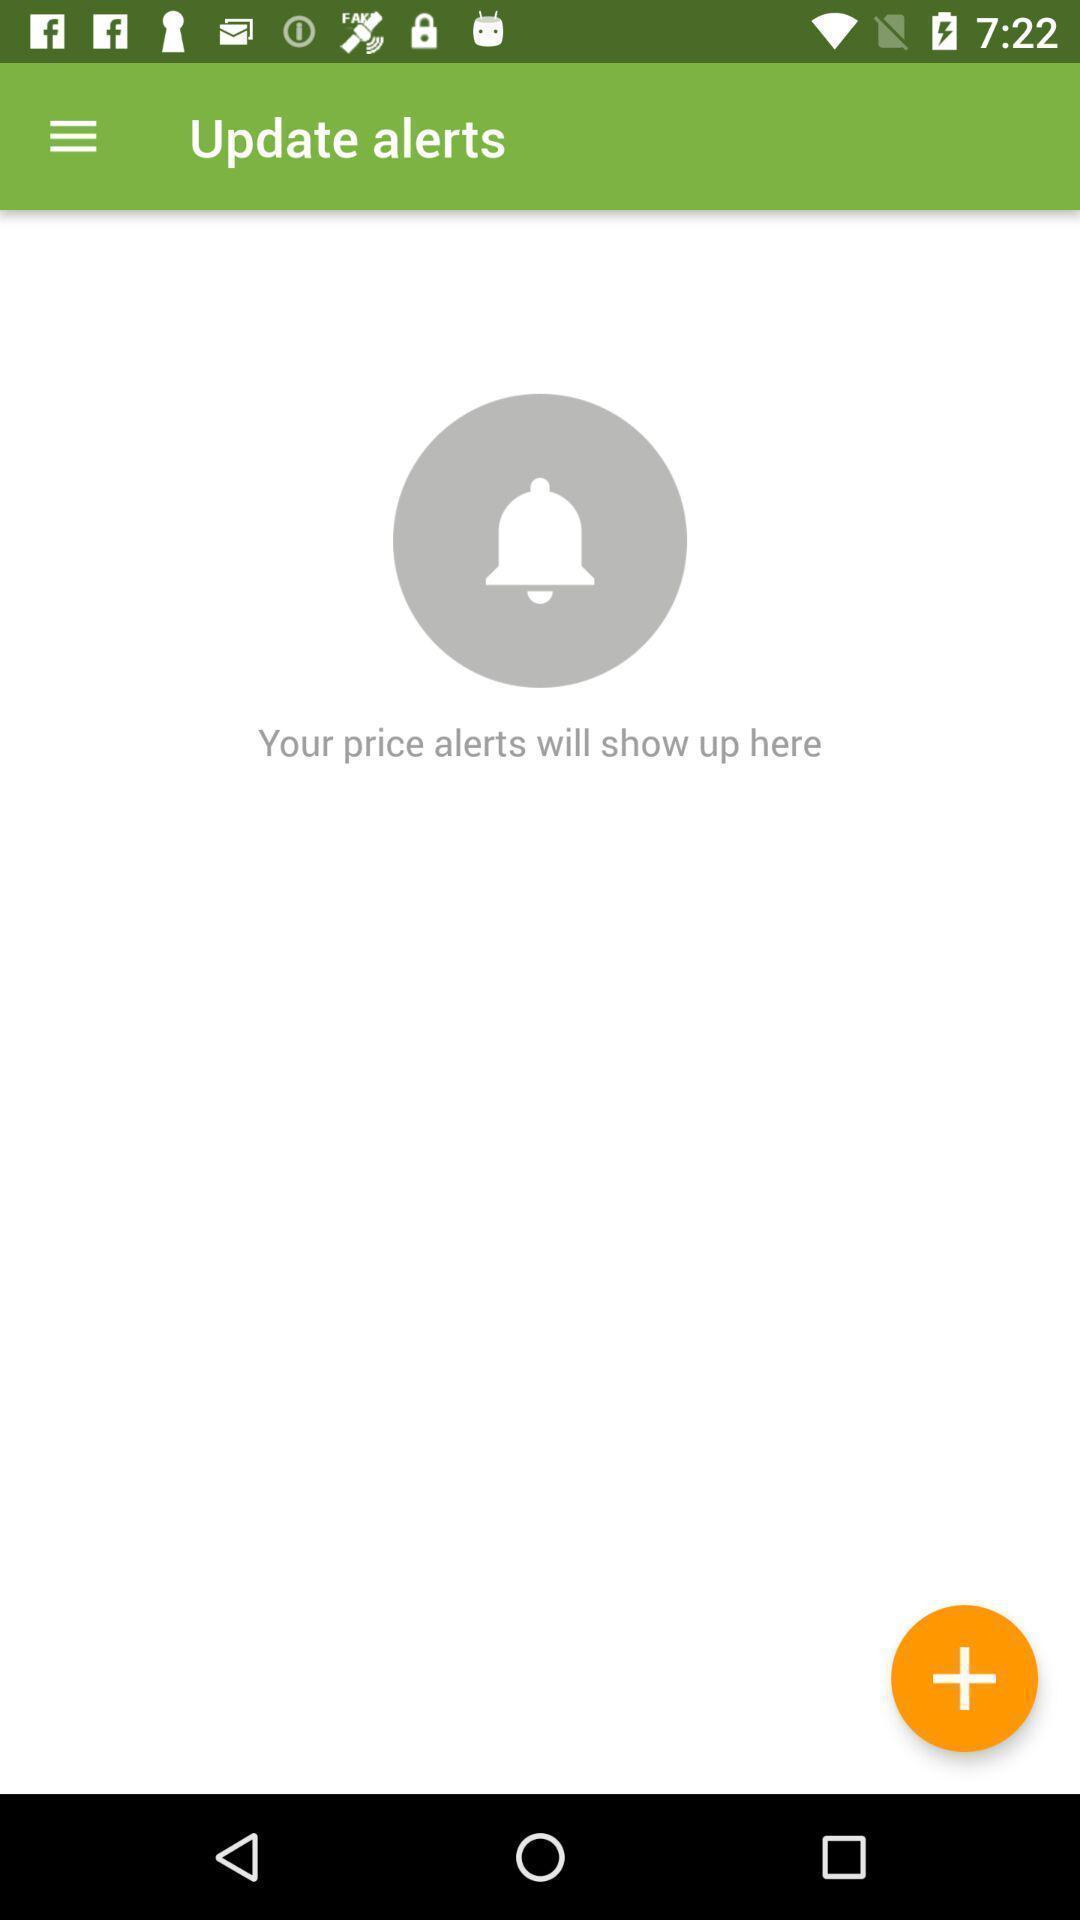Provide a textual representation of this image. Page for updating price alerts. 